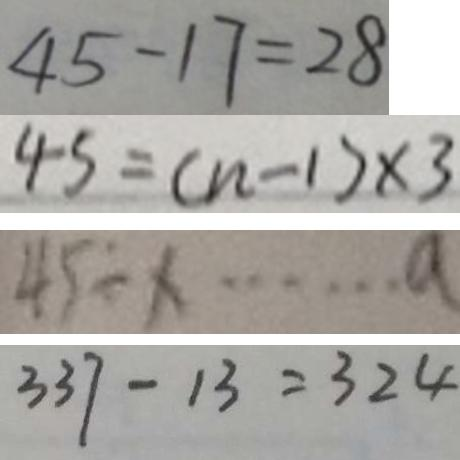Convert formula to latex. <formula><loc_0><loc_0><loc_500><loc_500>4 5 - 1 7 = 2 8 
 4 5 = ( n - 1 ) \times 3 
 4 5 \div x \cdots a 
 3 3 7 - 1 3 = 3 2 4</formula> 